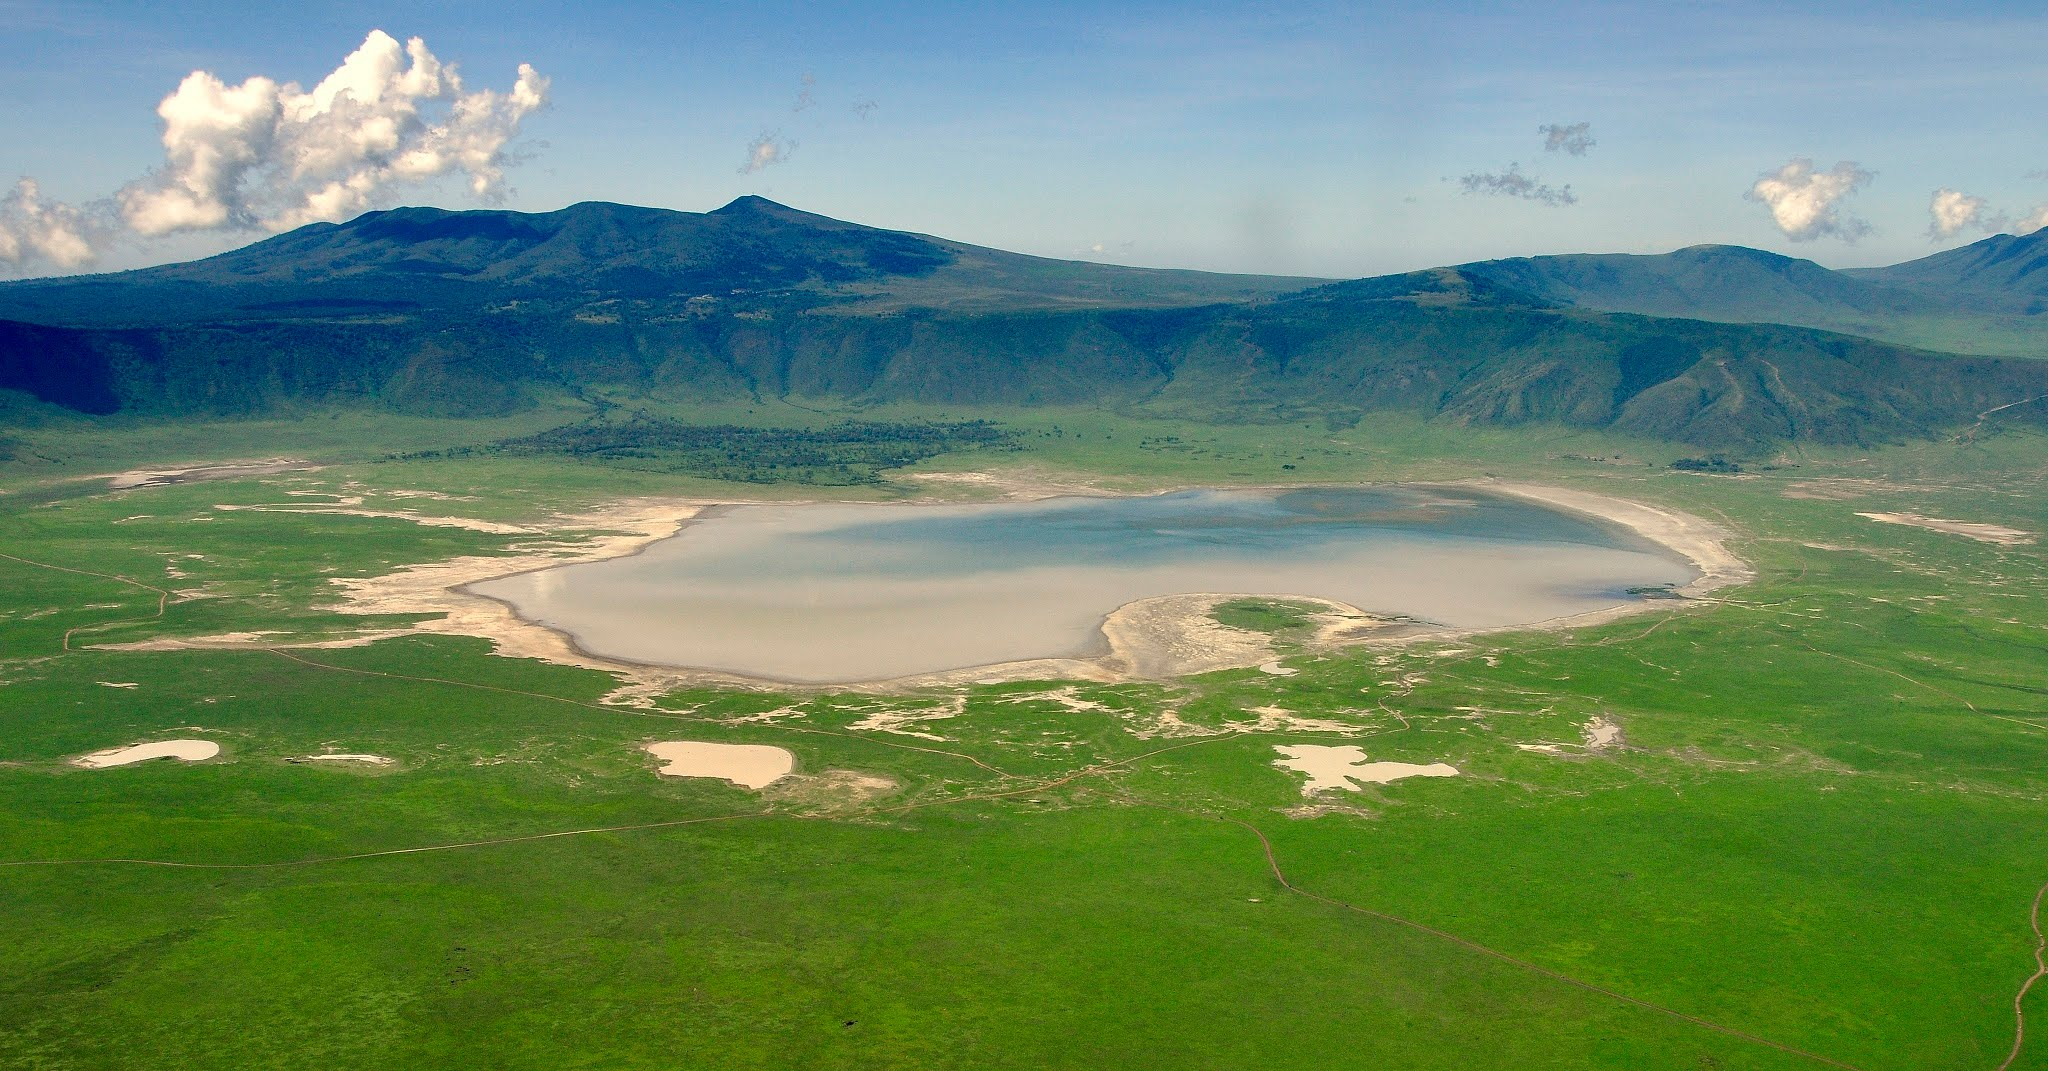Write a detailed description of the given image. The image showcases a spectacular aerial view of the Ngorongoro Crater, a prominent volcanic caldera located in Tanzania. At its center, there is a sizable shallow lake, its waters reflecting shades of blue and white. The crater walls ascend gradually, enveloping the lake with a rim of lush greenery. The surrounding landscape is primarily verdant with streaks of dry patches, indicative of varying soil moisture and vegetation cover. In the distance, towering mountains loom, adding a majestic backdrop to the scenery. The sky above is a clear, vibrant blue, embellished with puffy white clouds, enhancing the natural splendor of the scene. The overall perspective of the image is from high above, providing an expansive and detailed look at the geological marvel and the diverse ecosystem within and around Ngorongoro Crater. This remarkable photograph highlights the crater's natural beauty, ecological diversity, and geological importance to the Tanzanian landscape. 